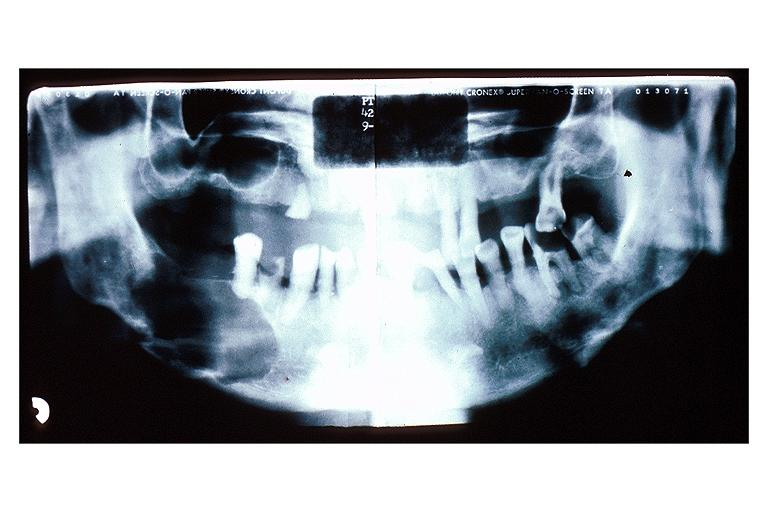what does this image show?
Answer the question using a single word or phrase. Multiple myeloma 